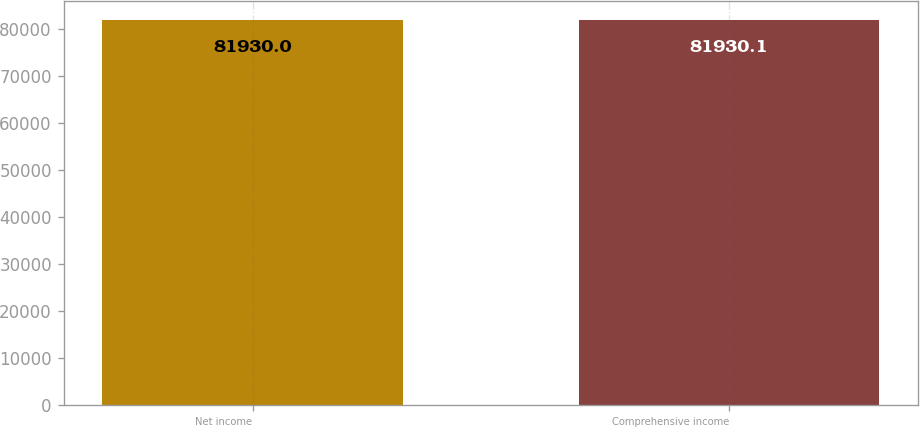<chart> <loc_0><loc_0><loc_500><loc_500><bar_chart><fcel>Net income<fcel>Comprehensive income<nl><fcel>81930<fcel>81930.1<nl></chart> 